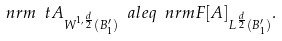Convert formula to latex. <formula><loc_0><loc_0><loc_500><loc_500>\ n r m { \ t A } _ { W ^ { 1 , \frac { d } { 2 } } ( B _ { 1 } ^ { \prime } ) } \ a l e q \ n r m { F [ A ] } _ { L ^ { \frac { d } { 2 } } ( B _ { 1 } ^ { \prime } ) } .</formula> 